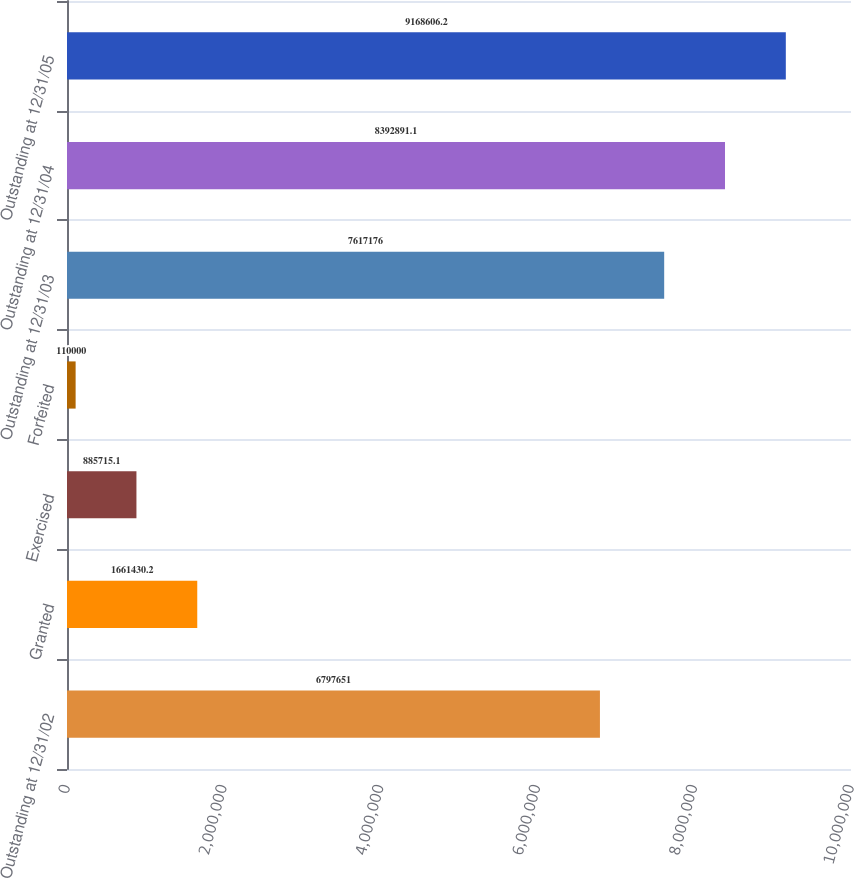Convert chart to OTSL. <chart><loc_0><loc_0><loc_500><loc_500><bar_chart><fcel>Outstanding at 12/31/02<fcel>Granted<fcel>Exercised<fcel>Forfeited<fcel>Outstanding at 12/31/03<fcel>Outstanding at 12/31/04<fcel>Outstanding at 12/31/05<nl><fcel>6.79765e+06<fcel>1.66143e+06<fcel>885715<fcel>110000<fcel>7.61718e+06<fcel>8.39289e+06<fcel>9.16861e+06<nl></chart> 